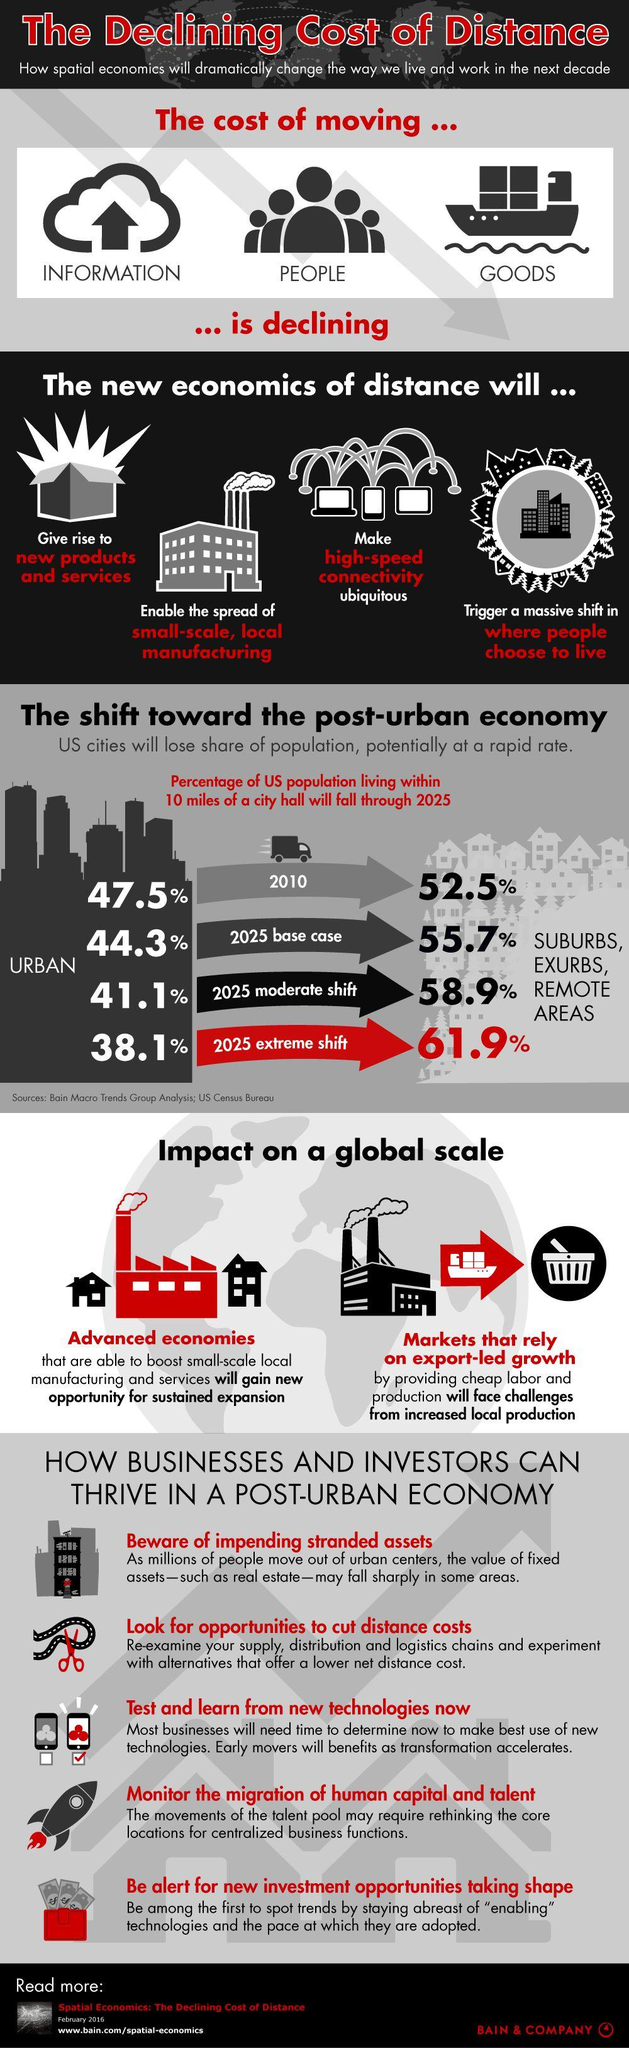Mention a couple of crucial points in this snapshot. In a post-urban economy, businesses can grow by looking for opportunities to reduce distance costs, which is the second tip listed for success. By the year 2025, the majority of people are likely to shift their living areas to suburbs, exurbs, and remote areas. The prediction is that the population of the urban area will be lower in 2025 than the suburban area. In a post-urban economy, advanced economies will gain new opportunities for sustained expansion, as they are better equipped to take advantage of the benefits of digital technologies and the decentralization of economic activity. In a post-urban economy, those who depend on export-led growth and face challenges from increased local production may struggle to compete. 